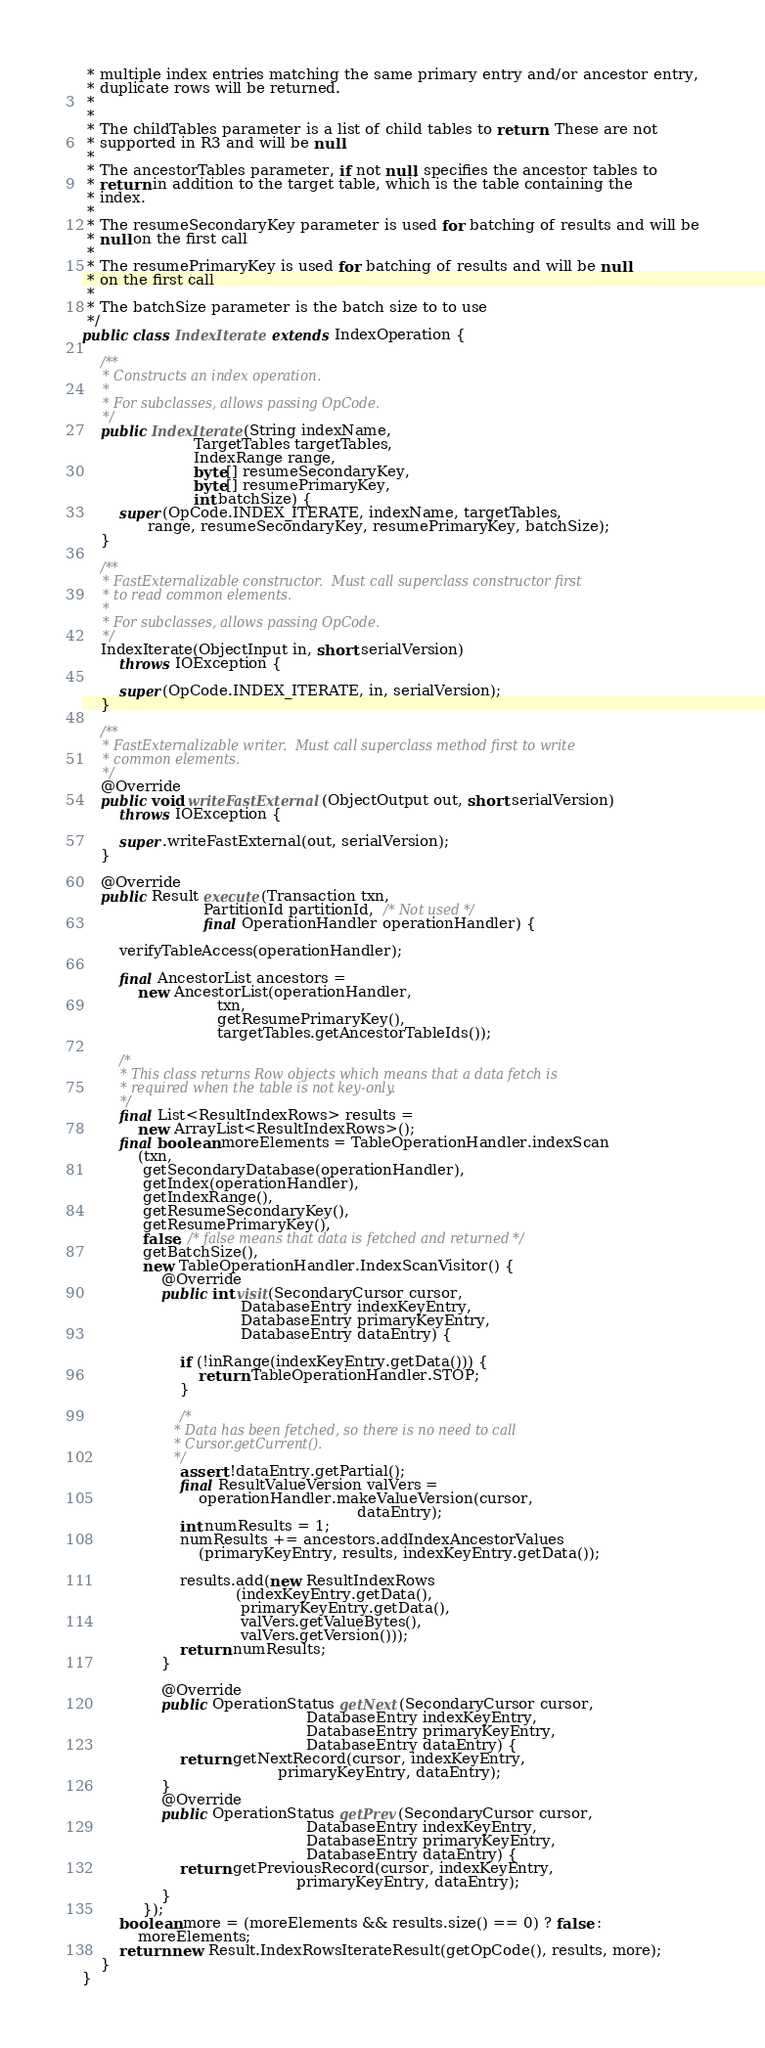Convert code to text. <code><loc_0><loc_0><loc_500><loc_500><_Java_> * multiple index entries matching the same primary entry and/or ancestor entry,
 * duplicate rows will be returned.
 *
 *
 * The childTables parameter is a list of child tables to return. These are not
 * supported in R3 and will be null.
 *
 * The ancestorTables parameter, if not null, specifies the ancestor tables to
 * return in addition to the target table, which is the table containing the
 * index.
 *
 * The resumeSecondaryKey parameter is used for batching of results and will be
 * null on the first call
 *
 * The resumePrimaryKey is used for batching of results and will be null
 * on the first call
 *
 * The batchSize parameter is the batch size to to use
 */
public class IndexIterate extends IndexOperation {

    /**
     * Constructs an index operation.
     *
     * For subclasses, allows passing OpCode.
     */
    public IndexIterate(String indexName,
                        TargetTables targetTables,
                        IndexRange range,
                        byte[] resumeSecondaryKey,
                        byte[] resumePrimaryKey,
                        int batchSize) {
        super(OpCode.INDEX_ITERATE, indexName, targetTables,
              range, resumeSecondaryKey, resumePrimaryKey, batchSize);
    }

    /**
     * FastExternalizable constructor.  Must call superclass constructor first
     * to read common elements.
     *
     * For subclasses, allows passing OpCode.
     */
    IndexIterate(ObjectInput in, short serialVersion)
        throws IOException {

        super(OpCode.INDEX_ITERATE, in, serialVersion);
    }

    /**
     * FastExternalizable writer.  Must call superclass method first to write
     * common elements.
     */
    @Override
    public void writeFastExternal(ObjectOutput out, short serialVersion)
        throws IOException {

        super.writeFastExternal(out, serialVersion);
    }

    @Override
    public Result execute(Transaction txn,
                          PartitionId partitionId,  /* Not used */
                          final OperationHandler operationHandler) {

        verifyTableAccess(operationHandler);

        final AncestorList ancestors =
            new AncestorList(operationHandler,
                             txn,
                             getResumePrimaryKey(),
                             targetTables.getAncestorTableIds());

        /*
         * This class returns Row objects which means that a data fetch is
         * required when the table is not key-only.
         */
        final List<ResultIndexRows> results =
            new ArrayList<ResultIndexRows>();
        final boolean moreElements = TableOperationHandler.indexScan
            (txn,
             getSecondaryDatabase(operationHandler),
             getIndex(operationHandler),
             getIndexRange(),
             getResumeSecondaryKey(),
             getResumePrimaryKey(),
             false, /* false means that data is fetched and returned */
             getBatchSize(),
             new TableOperationHandler.IndexScanVisitor() {
                 @Override
                 public int visit(SecondaryCursor cursor,
                                  DatabaseEntry indexKeyEntry,
                                  DatabaseEntry primaryKeyEntry,
                                  DatabaseEntry dataEntry) {

                     if (!inRange(indexKeyEntry.getData())) {
                         return TableOperationHandler.STOP;
                     }

                     /*
                      * Data has been fetched, so there is no need to call
                      * Cursor.getCurrent().
                      */
                     assert !dataEntry.getPartial();
                     final ResultValueVersion valVers =
                         operationHandler.makeValueVersion(cursor,
                                                           dataEntry);
                     int numResults = 1;
                     numResults += ancestors.addIndexAncestorValues
                         (primaryKeyEntry, results, indexKeyEntry.getData());

                     results.add(new ResultIndexRows
                                 (indexKeyEntry.getData(),
                                  primaryKeyEntry.getData(),
                                  valVers.getValueBytes(),
                                  valVers.getVersion()));
                     return numResults;
                 }

                 @Override
                 public OperationStatus getNext(SecondaryCursor cursor,
                                                DatabaseEntry indexKeyEntry,
                                                DatabaseEntry primaryKeyEntry,
                                                DatabaseEntry dataEntry) {
                     return getNextRecord(cursor, indexKeyEntry,
                                          primaryKeyEntry, dataEntry);
                 }
                 @Override
                 public OperationStatus getPrev(SecondaryCursor cursor,
                                                DatabaseEntry indexKeyEntry,
                                                DatabaseEntry primaryKeyEntry,
                                                DatabaseEntry dataEntry) {
                     return getPreviousRecord(cursor, indexKeyEntry,
                                              primaryKeyEntry, dataEntry);
                 }
             });
        boolean more = (moreElements && results.size() == 0) ? false :
            moreElements;
        return new Result.IndexRowsIterateResult(getOpCode(), results, more);
    }
}
</code> 